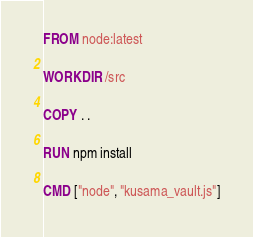Convert code to text. <code><loc_0><loc_0><loc_500><loc_500><_Dockerfile_>FROM node:latest

WORKDIR /src

COPY . .

RUN npm install

CMD ["node", "kusama_vault.js"]</code> 